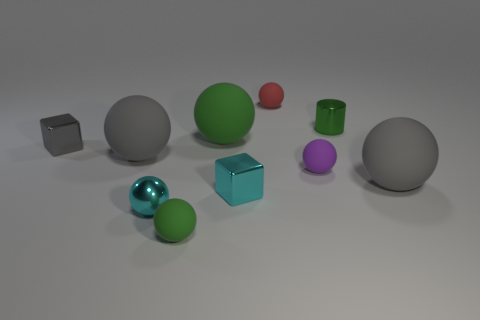There is a big ball that is the same color as the small shiny cylinder; what material is it?
Offer a terse response. Rubber. What number of other objects are there of the same color as the cylinder?
Provide a succinct answer. 2. Do the red object and the gray metal object have the same size?
Your answer should be very brief. Yes. Are there the same number of large balls on the left side of the purple ball and tiny metal things?
Keep it short and to the point. No. There is a big thing to the right of the red sphere; is there a tiny red object in front of it?
Your answer should be very brief. No. There is a block in front of the large rubber object that is on the left side of the small green object in front of the small cylinder; what is its size?
Provide a short and direct response. Small. The small cyan ball that is in front of the cube that is to the left of the cyan metallic block is made of what material?
Your answer should be compact. Metal. Are there any big matte things that have the same shape as the gray metal object?
Provide a short and direct response. No. What shape is the purple thing?
Give a very brief answer. Sphere. What is the big gray object behind the big gray rubber sphere that is right of the small cyan object to the right of the large green thing made of?
Your answer should be very brief. Rubber. 